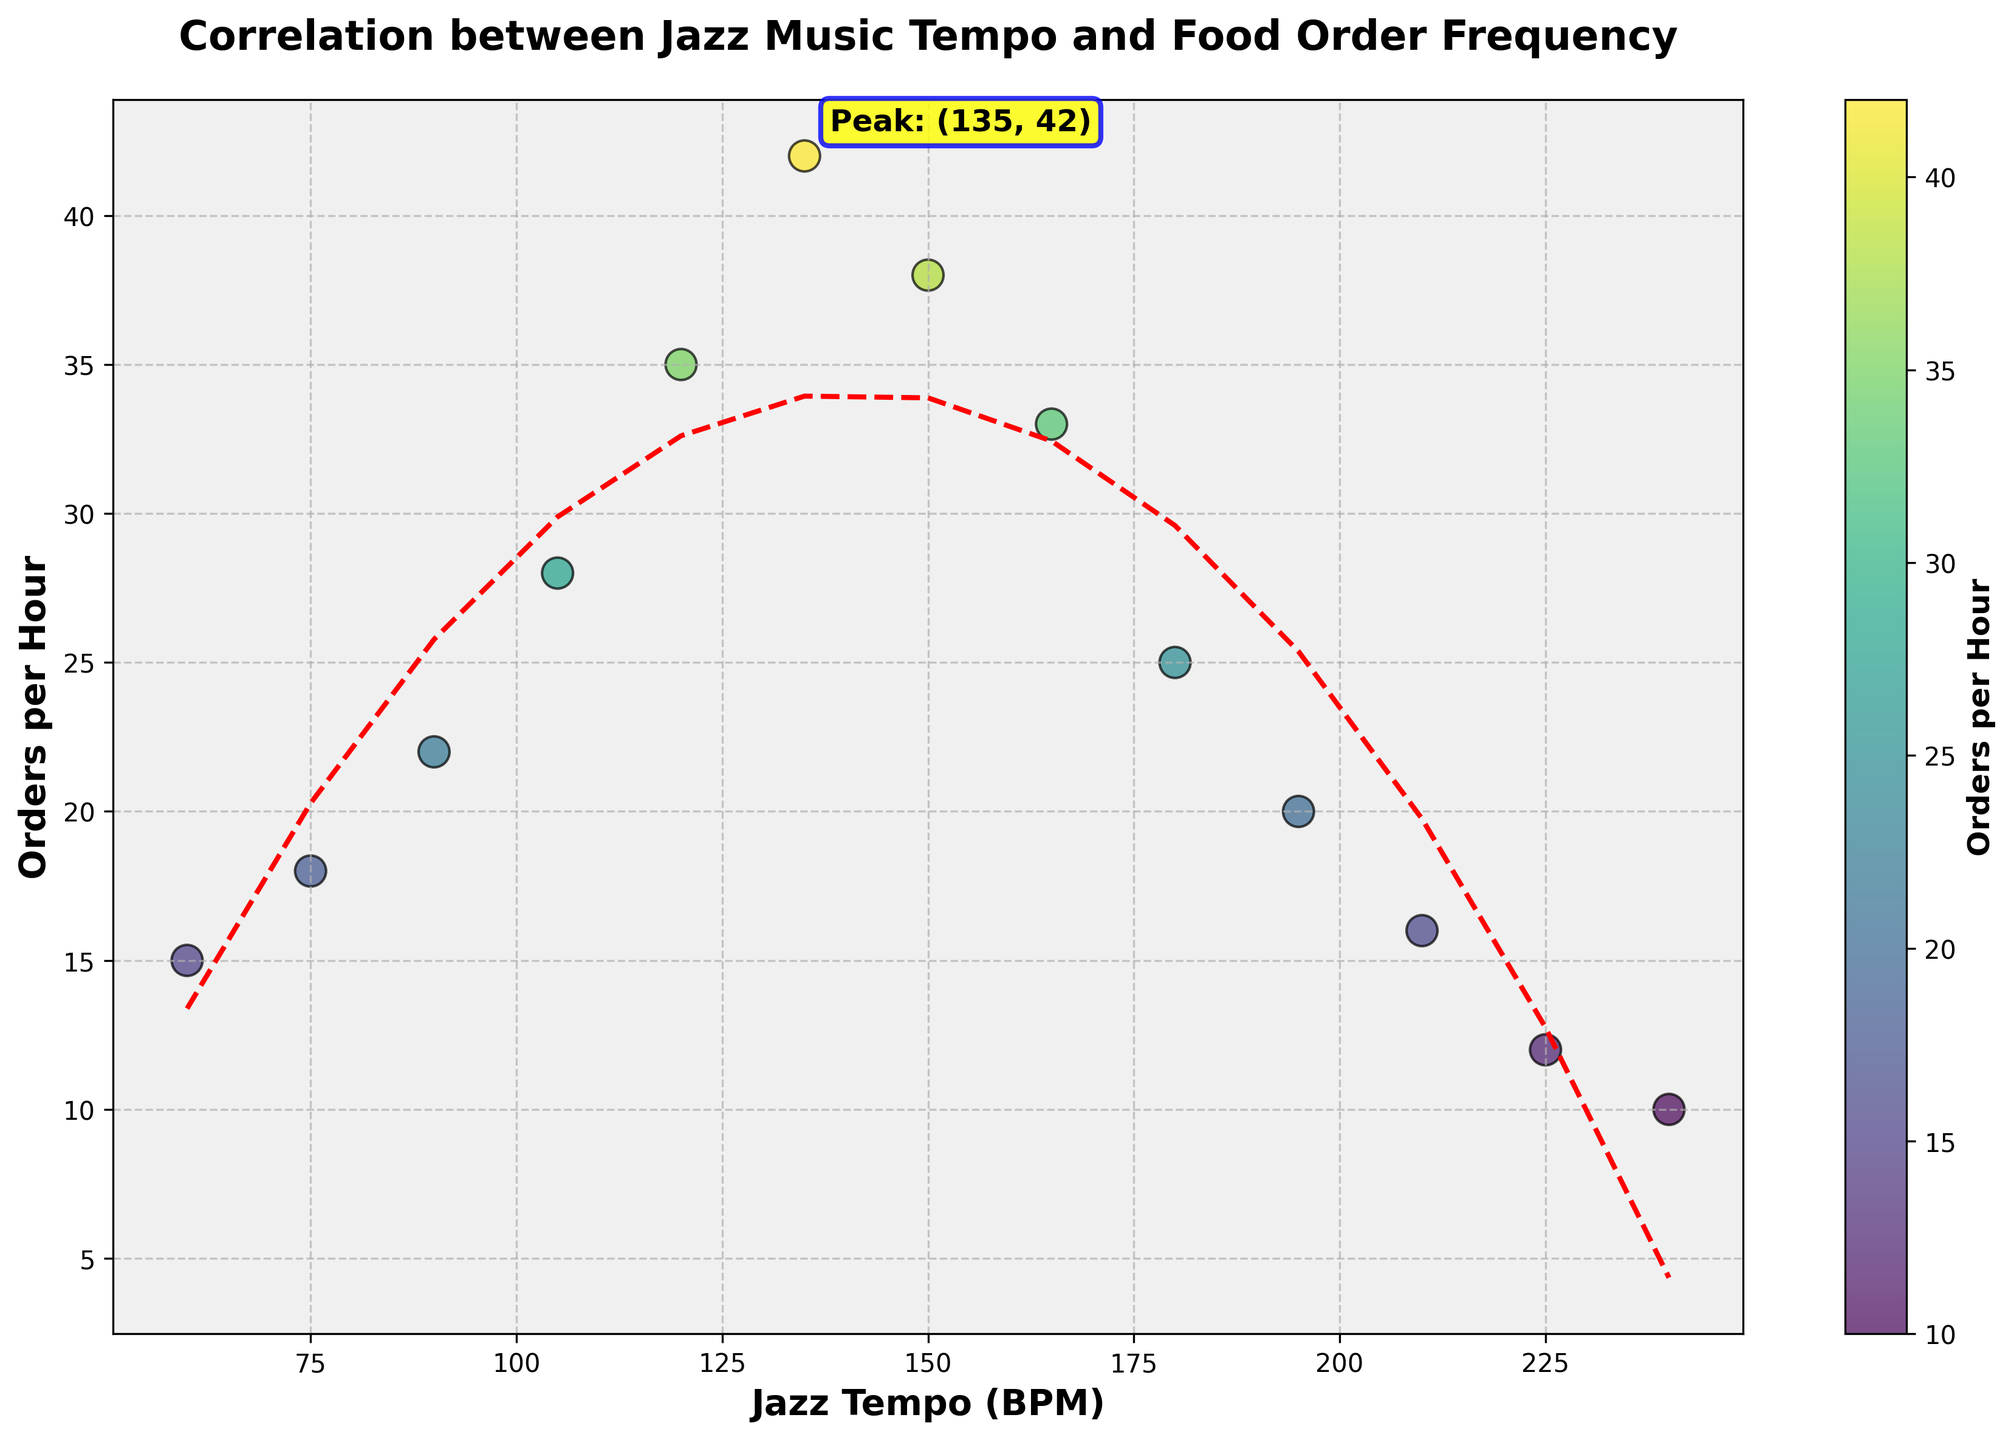What's the title of the figure? The title of the figure is usually located at the top. In this case, it reads "Correlation between Jazz Music Tempo and Food Order Frequency."
Answer: Correlation between Jazz Music Tempo and Food Order Frequency What is the peak value of food orders per hour, and at what tempo does it occur? The peak value is the highest point in the y-axis, which is annotated in the figure. It shows the peak value of 42 orders at a tempo of 135 BPM.
Answer: 42 orders at 135 BPM How does the color vary across different data points, and what does it represent? The scatter plot uses a color gradient from the 'viridis' color map, with the color indicating the number of orders per hour. Darker colors represent lower orders, while brighter colors represent higher orders.
Answer: Color represents the number of orders per hour What trend can be observed between jazz tempo and food orders? By observing the trend line (red dashed line) added to the scatter plot, we can see an upward trend reaching a peak and then a downward trend, indicating a polynomial relationship where food orders increase with tempo up to a point and then decrease.
Answer: Polynomial relationship, peak then decline At what tempo range do the orders start to decline after the peak? The orders start to decline after the peak value of 135 BPM. By following the red trend line and scatter points, the decline can be observed from 150 BPM onwards.
Answer: From 150 BPM onwards Is there a tempo where orders remain relatively constant? Orders per hour do not remain constant across any tempo. However, a flatter region where the change is not as sharp can be seen around 105-120 BPM, where the increase is steady.
Answer: Around 105-120 BPM (steady increase) Compare the food orders at 90 BPM and 180 BPM. Which is higher and by how much? By looking at the scatter points, orders at 90 BPM are 22, while at 180 BPM, they are 25. The orders at 180 BPM are higher by 3.
Answer: 180 BPM is higher by 3 orders How many data points indicate the declining phase on the scatter plot? The declining phase starts after the peak at 135 BPM. Counting the data points from 135 BPM onwards: 7 points are part of the declining phase.
Answer: 7 points What does the x-axis and y-axis represent in this figure? The x-axis represents the jazz tempo in beats per minute (BPM), and the y-axis represents the number of food orders per hour.
Answer: Jazz tempo in BPM and Orders per Hour 